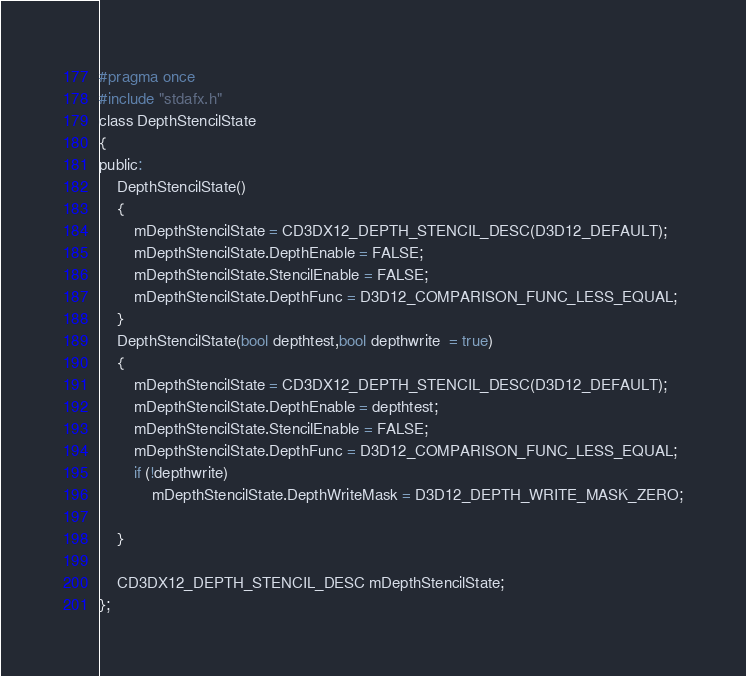<code> <loc_0><loc_0><loc_500><loc_500><_C_>#pragma once
#include "stdafx.h"
class DepthStencilState
{
public:
	DepthStencilState()
	{
		mDepthStencilState = CD3DX12_DEPTH_STENCIL_DESC(D3D12_DEFAULT);
		mDepthStencilState.DepthEnable = FALSE;
		mDepthStencilState.StencilEnable = FALSE;
		mDepthStencilState.DepthFunc = D3D12_COMPARISON_FUNC_LESS_EQUAL;
	}
	DepthStencilState(bool depthtest,bool depthwrite  = true)
	{
		mDepthStencilState = CD3DX12_DEPTH_STENCIL_DESC(D3D12_DEFAULT);
		mDepthStencilState.DepthEnable = depthtest;
		mDepthStencilState.StencilEnable = FALSE;
		mDepthStencilState.DepthFunc = D3D12_COMPARISON_FUNC_LESS_EQUAL;
		if (!depthwrite)
			mDepthStencilState.DepthWriteMask = D3D12_DEPTH_WRITE_MASK_ZERO;

	}

	CD3DX12_DEPTH_STENCIL_DESC mDepthStencilState;
};</code> 